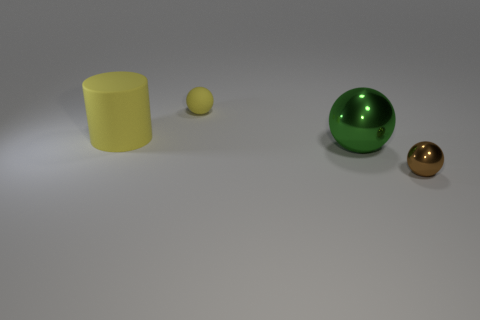Subtract all red cylinders. Subtract all green blocks. How many cylinders are left? 1 Add 3 big brown metallic cylinders. How many objects exist? 7 Subtract all spheres. How many objects are left? 1 Add 3 tiny things. How many tiny things are left? 5 Add 4 big matte balls. How many big matte balls exist? 4 Subtract 0 gray blocks. How many objects are left? 4 Subtract all big green metal spheres. Subtract all small shiny things. How many objects are left? 2 